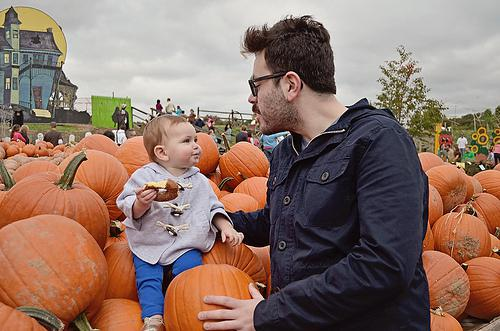Question: what is the baby sitting on?
Choices:
A. Watermelons.
B. Pumpkins.
C. Hay.
D. Trees.
Answer with the letter. Answer: B Question: what is in the baby's hand?
Choices:
A. Bread.
B. Donut.
C. Bear claw.
D. Cinnamon roll.
Answer with the letter. Answer: B Question: what color pants is the baby wearing?
Choices:
A. Black.
B. Pink.
C. Blue.
D. Red.
Answer with the letter. Answer: C Question: what has dirt on them?
Choices:
A. Peaches.
B. Watermelons.
C. Apples.
D. Pumpkins.
Answer with the letter. Answer: D Question: where was the photo taken?
Choices:
A. At a pumpkin patch.
B. At the farm.
C. In the garden.
D. In the desert.
Answer with the letter. Answer: A Question: when was the photo taken?
Choices:
A. Nighttime.
B. Morning time.
C. Daytime.
D. Sunset.
Answer with the letter. Answer: C Question: what kind of flowers can be seen on the right?
Choices:
A. Daisies.
B. Sun flowers.
C. Roses.
D. Tulips.
Answer with the letter. Answer: B 